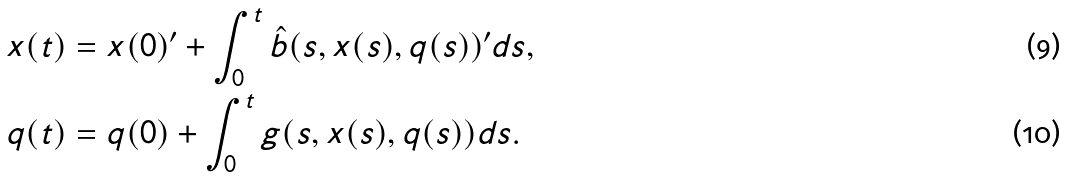<formula> <loc_0><loc_0><loc_500><loc_500>x ( t ) & = x ( 0 ) ^ { \prime } + \int _ { 0 } ^ { t } \hat { b } ( s , x ( s ) , q ( s ) ) ^ { \prime } d s , \\ q ( t ) & = q ( 0 ) + \int _ { 0 } ^ { t } g ( s , x ( s ) , q ( s ) ) d s .</formula> 